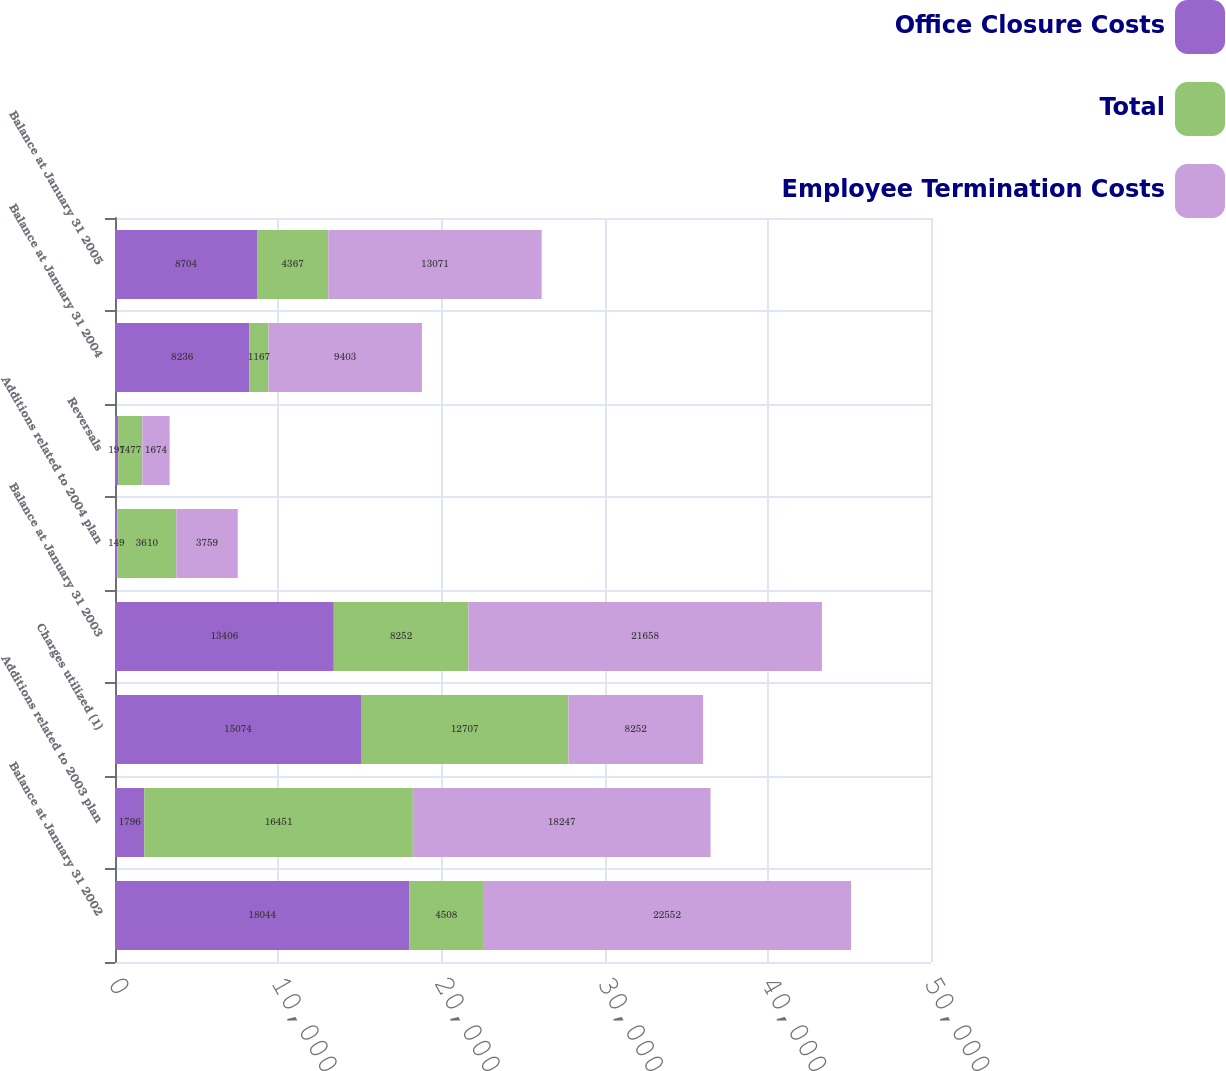Convert chart to OTSL. <chart><loc_0><loc_0><loc_500><loc_500><stacked_bar_chart><ecel><fcel>Balance at January 31 2002<fcel>Additions related to 2003 plan<fcel>Charges utilized (1)<fcel>Balance at January 31 2003<fcel>Additions related to 2004 plan<fcel>Reversals<fcel>Balance at January 31 2004<fcel>Balance at January 31 2005<nl><fcel>Office Closure Costs<fcel>18044<fcel>1796<fcel>15074<fcel>13406<fcel>149<fcel>197<fcel>8236<fcel>8704<nl><fcel>Total<fcel>4508<fcel>16451<fcel>12707<fcel>8252<fcel>3610<fcel>1477<fcel>1167<fcel>4367<nl><fcel>Employee Termination Costs<fcel>22552<fcel>18247<fcel>8252<fcel>21658<fcel>3759<fcel>1674<fcel>9403<fcel>13071<nl></chart> 